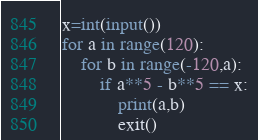Convert code to text. <code><loc_0><loc_0><loc_500><loc_500><_Python_>x=int(input())
for a in range(120):
    for b in range(-120,a):
        if a**5 - b**5 == x:
            print(a,b)
            exit()</code> 